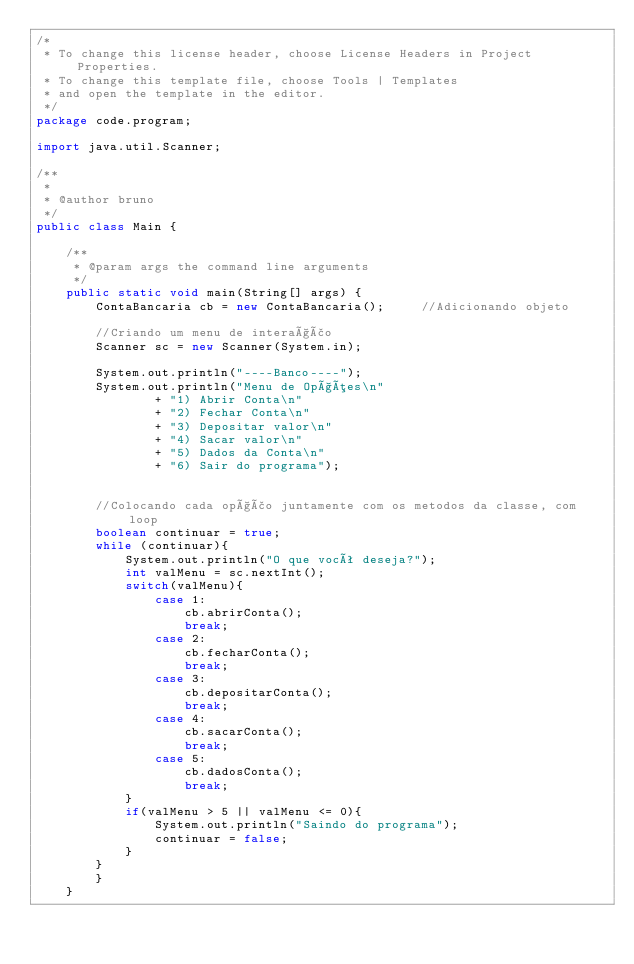Convert code to text. <code><loc_0><loc_0><loc_500><loc_500><_Java_>/*
 * To change this license header, choose License Headers in Project Properties.
 * To change this template file, choose Tools | Templates
 * and open the template in the editor.
 */
package code.program;

import java.util.Scanner;

/**
 *
 * @author bruno
 */
public class Main {

    /**
     * @param args the command line arguments
     */
    public static void main(String[] args) {
        ContaBancaria cb = new ContaBancaria();     //Adicionando objeto
        
        //Criando um menu de interação
        Scanner sc = new Scanner(System.in);
        
        System.out.println("----Banco----");
        System.out.println("Menu de Opções\n"
                + "1) Abrir Conta\n"
                + "2) Fechar Conta\n"
                + "3) Depositar valor\n"
                + "4) Sacar valor\n"
                + "5) Dados da Conta\n"
                + "6) Sair do programa");
        
        
        //Colocando cada opção juntamente com os metodos da classe, com loop
        boolean continuar = true;
        while (continuar){
            System.out.println("O que você deseja?");
            int valMenu = sc.nextInt();
            switch(valMenu){
                case 1:
                    cb.abrirConta();
                    break;
                case 2:
                    cb.fecharConta();
                    break;
                case 3:
                    cb.depositarConta();
                    break;
                case 4:
                    cb.sacarConta();
                    break;
                case 5:
                    cb.dadosConta();
                    break;
            }
            if(valMenu > 5 || valMenu <= 0){
                System.out.println("Saindo do programa");
                continuar = false;
            }
        }
        }
    }
</code> 